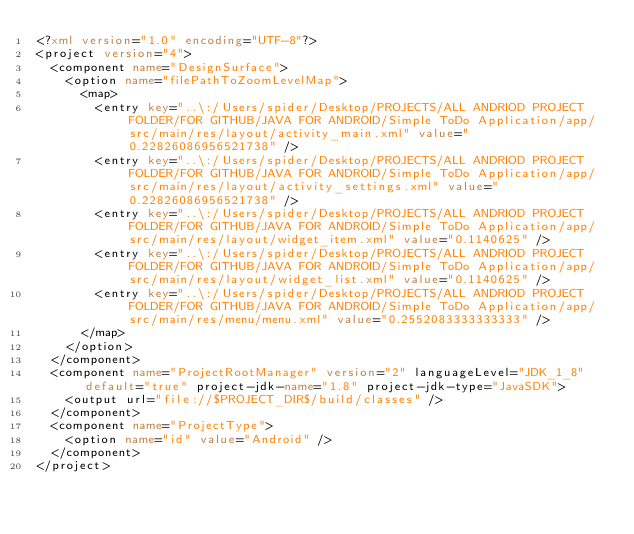<code> <loc_0><loc_0><loc_500><loc_500><_XML_><?xml version="1.0" encoding="UTF-8"?>
<project version="4">
  <component name="DesignSurface">
    <option name="filePathToZoomLevelMap">
      <map>
        <entry key="..\:/Users/spider/Desktop/PROJECTS/ALL ANDRIOD PROJECT FOLDER/FOR GITHUB/JAVA FOR ANDROID/Simple ToDo Application/app/src/main/res/layout/activity_main.xml" value="0.22826086956521738" />
        <entry key="..\:/Users/spider/Desktop/PROJECTS/ALL ANDRIOD PROJECT FOLDER/FOR GITHUB/JAVA FOR ANDROID/Simple ToDo Application/app/src/main/res/layout/activity_settings.xml" value="0.22826086956521738" />
        <entry key="..\:/Users/spider/Desktop/PROJECTS/ALL ANDRIOD PROJECT FOLDER/FOR GITHUB/JAVA FOR ANDROID/Simple ToDo Application/app/src/main/res/layout/widget_item.xml" value="0.1140625" />
        <entry key="..\:/Users/spider/Desktop/PROJECTS/ALL ANDRIOD PROJECT FOLDER/FOR GITHUB/JAVA FOR ANDROID/Simple ToDo Application/app/src/main/res/layout/widget_list.xml" value="0.1140625" />
        <entry key="..\:/Users/spider/Desktop/PROJECTS/ALL ANDRIOD PROJECT FOLDER/FOR GITHUB/JAVA FOR ANDROID/Simple ToDo Application/app/src/main/res/menu/menu.xml" value="0.2552083333333333" />
      </map>
    </option>
  </component>
  <component name="ProjectRootManager" version="2" languageLevel="JDK_1_8" default="true" project-jdk-name="1.8" project-jdk-type="JavaSDK">
    <output url="file://$PROJECT_DIR$/build/classes" />
  </component>
  <component name="ProjectType">
    <option name="id" value="Android" />
  </component>
</project></code> 